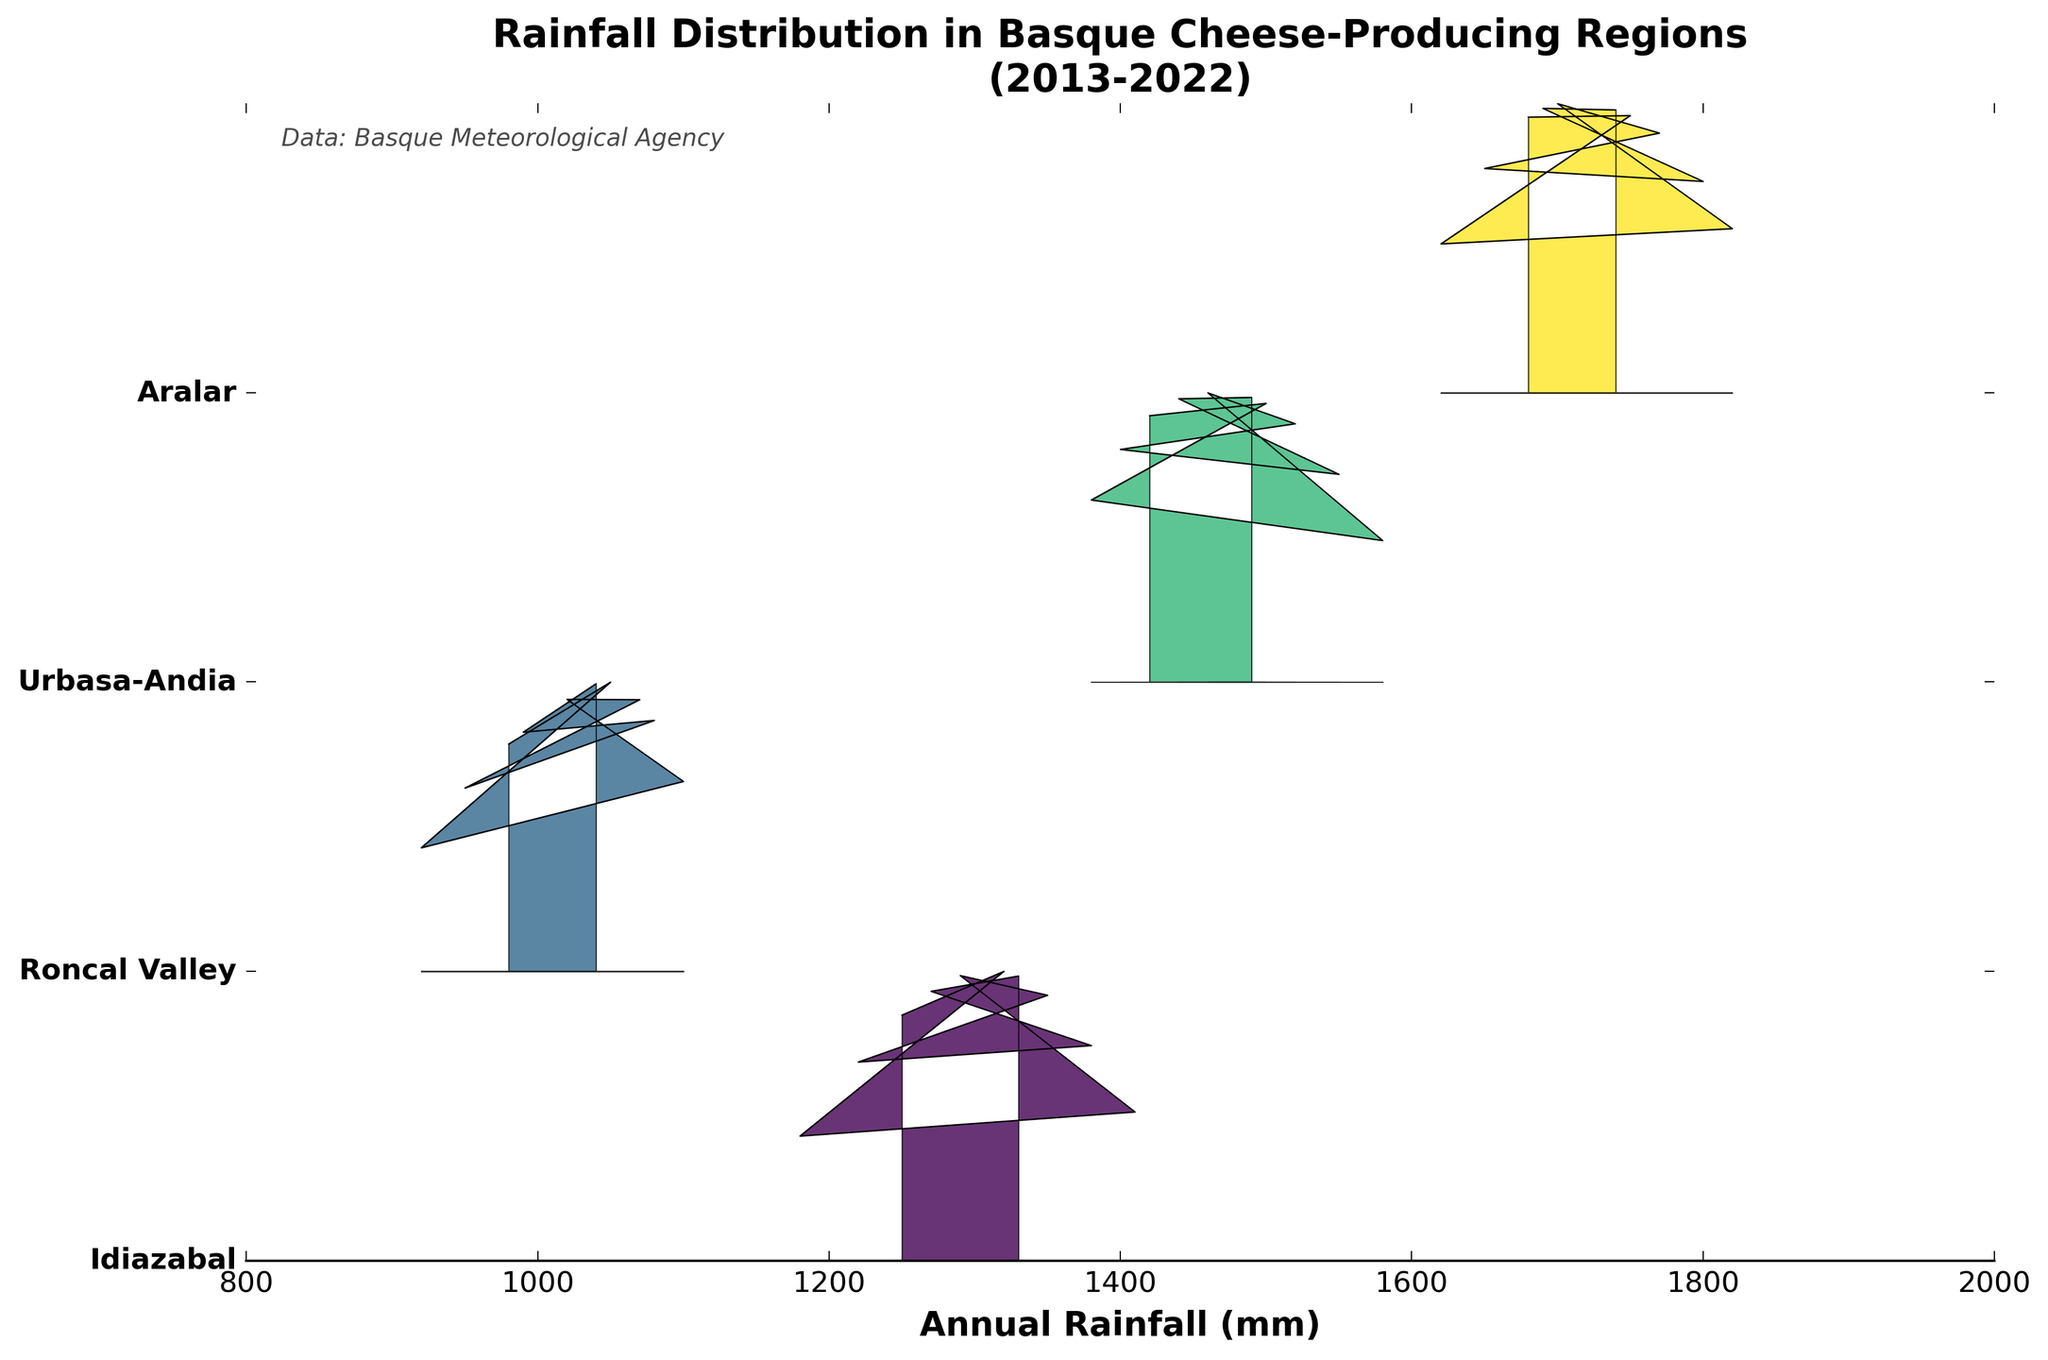What's the title of the plot? The title of the plot is prominently displayed at the top of the figure. It summarizes the main focus of the visualization, which is the rainfall distribution across different regions.
Answer: Rainfall Distribution in Basque Cheese-Producing Regions (2013-2022) How many different regions are represented in the plot? The number of different regions can be counted by looking at the distinct labels on the y-axis. Each label corresponds to one region.
Answer: 4 Which region appears to have the highest average annual rainfall? To identify the region with the highest average annual rainfall, look for the region whose plot is shifted furthest to the right. This indicates higher values of rainfall.
Answer: Aralar Do any regions show noticeable fluctuation in their rainfall patterns? Regions with noticeable fluctuation in rainfall patterns will have distributions that spread widely and have multiple peaks or irregular shapes. These patterns indicate variability over the years.
Answer: Yes How does Idiazabal's rainfall compare to Roncal Valley's? To compare the rainfall between Idiazabal and Roncal Valley, observe their respective ridgeline plots. Idiazabal's plot should be to the right of Roncal Valley's if it has higher rainfall.
Answer: Idiazabal has higher rainfall Which region has the least variation in annual rainfall? The region with the least variation will have a narrow and concentrated distribution in its ridgeline plot, indicating less spread and more consistency in rainfall data.
Answer: Roncal Valley What is the range of rainfall values for Urbasa-Andia? The range can be determined by finding the minimum and maximum values represented in Urbasa-Andia's distribution. This region's plot extends from its lowest to highest values of rainfall.
Answer: 1380-1580 mm How does Aralar's rainfall in 2016 compare to other years within the same region? To compare, look specifically at the peak of Aralar's ridgeline plot in 2016 and see how it stands relative to other peaks within Aralar's plot. The height and position give an indication of how it fares.
Answer: Higher than most other years What can you infer about the overall rainfall trend in these regions over the decade? By evaluating the rainfall distributions over the decade for each region, note if the patterns are shifting left or right (indicating decreasing or increasing trends) and whether variability is increasing or decreasing.
Answer: Most regions show consistent patterns with some increasing trends Is there any region that showed a particularly wet or particularly dry year over the decade? Look for any individual peaks that are significantly higher or lower compared to other peaks in a region. This indicates an exceptionally wet or dry year.
Answer: Urbasa-Andia in 2016 was particularly wet 